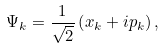Convert formula to latex. <formula><loc_0><loc_0><loc_500><loc_500>\Psi _ { k } = \frac { 1 } { \sqrt { 2 } } \left ( x _ { k } + i p _ { k } \right ) ,</formula> 